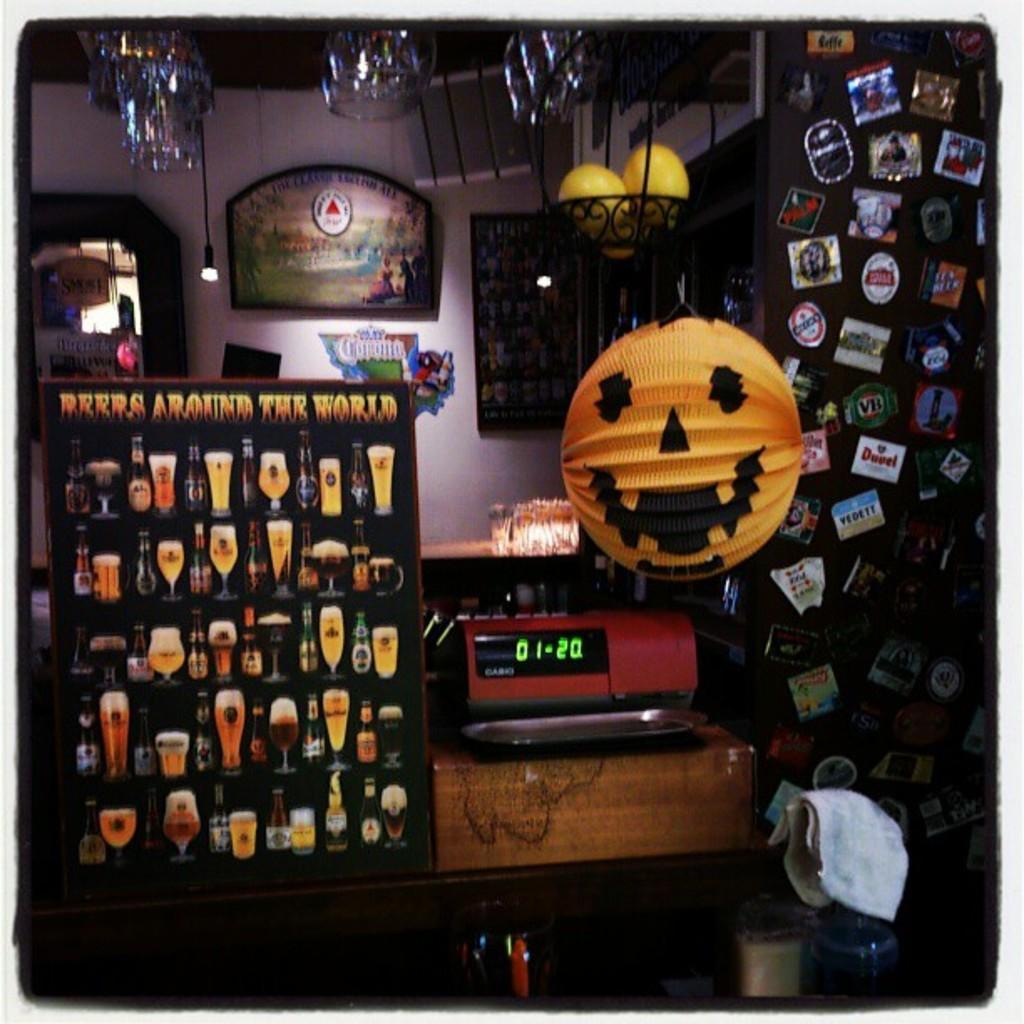In one or two sentences, can you explain what this image depicts? In this picture I can see many stickers and posters were placed on this board. On the table I can see the weight machine or timer. In the center I can see the pumpkin toy which is hanging from the roof. In the background I can see the painting frame and bouquet which is placed on the wall near to the door and window. At the top I can see the glasses which is placed on the roof. 